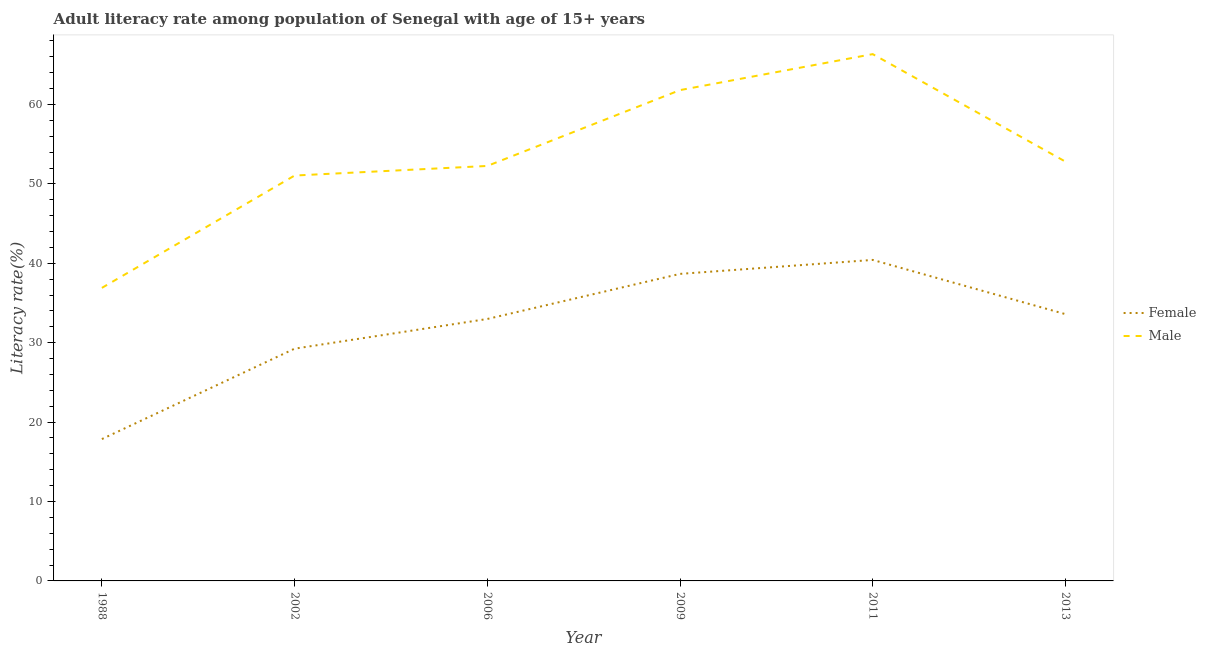Is the number of lines equal to the number of legend labels?
Make the answer very short. Yes. What is the male adult literacy rate in 1988?
Give a very brief answer. 36.9. Across all years, what is the maximum female adult literacy rate?
Offer a terse response. 40.42. Across all years, what is the minimum female adult literacy rate?
Give a very brief answer. 17.86. What is the total female adult literacy rate in the graph?
Your answer should be very brief. 192.79. What is the difference between the female adult literacy rate in 2002 and that in 2009?
Offer a terse response. -9.42. What is the difference between the female adult literacy rate in 2009 and the male adult literacy rate in 2006?
Offer a very short reply. -13.59. What is the average male adult literacy rate per year?
Provide a succinct answer. 53.53. In the year 2011, what is the difference between the male adult literacy rate and female adult literacy rate?
Offer a very short reply. 25.92. In how many years, is the male adult literacy rate greater than 4 %?
Your answer should be compact. 6. What is the ratio of the female adult literacy rate in 2002 to that in 2013?
Your answer should be compact. 0.87. What is the difference between the highest and the second highest female adult literacy rate?
Your answer should be very brief. 1.76. What is the difference between the highest and the lowest male adult literacy rate?
Keep it short and to the point. 29.44. In how many years, is the female adult literacy rate greater than the average female adult literacy rate taken over all years?
Provide a succinct answer. 4. How many lines are there?
Make the answer very short. 2. How many years are there in the graph?
Ensure brevity in your answer.  6. Are the values on the major ticks of Y-axis written in scientific E-notation?
Provide a succinct answer. No. Where does the legend appear in the graph?
Your answer should be compact. Center right. What is the title of the graph?
Provide a short and direct response. Adult literacy rate among population of Senegal with age of 15+ years. Does "Number of arrivals" appear as one of the legend labels in the graph?
Ensure brevity in your answer.  No. What is the label or title of the X-axis?
Make the answer very short. Year. What is the label or title of the Y-axis?
Provide a succinct answer. Literacy rate(%). What is the Literacy rate(%) of Female in 1988?
Make the answer very short. 17.86. What is the Literacy rate(%) in Male in 1988?
Your answer should be compact. 36.9. What is the Literacy rate(%) of Female in 2002?
Offer a terse response. 29.25. What is the Literacy rate(%) of Male in 2002?
Provide a succinct answer. 51.05. What is the Literacy rate(%) in Female in 2006?
Give a very brief answer. 32.99. What is the Literacy rate(%) of Male in 2006?
Your answer should be compact. 52.26. What is the Literacy rate(%) of Female in 2009?
Give a very brief answer. 38.67. What is the Literacy rate(%) in Male in 2009?
Provide a short and direct response. 61.81. What is the Literacy rate(%) in Female in 2011?
Make the answer very short. 40.42. What is the Literacy rate(%) of Male in 2011?
Make the answer very short. 66.34. What is the Literacy rate(%) in Female in 2013?
Provide a succinct answer. 33.6. What is the Literacy rate(%) of Male in 2013?
Your answer should be very brief. 52.8. Across all years, what is the maximum Literacy rate(%) in Female?
Keep it short and to the point. 40.42. Across all years, what is the maximum Literacy rate(%) of Male?
Offer a terse response. 66.34. Across all years, what is the minimum Literacy rate(%) of Female?
Your answer should be very brief. 17.86. Across all years, what is the minimum Literacy rate(%) in Male?
Your answer should be compact. 36.9. What is the total Literacy rate(%) in Female in the graph?
Make the answer very short. 192.79. What is the total Literacy rate(%) of Male in the graph?
Provide a short and direct response. 321.17. What is the difference between the Literacy rate(%) in Female in 1988 and that in 2002?
Make the answer very short. -11.38. What is the difference between the Literacy rate(%) of Male in 1988 and that in 2002?
Keep it short and to the point. -14.15. What is the difference between the Literacy rate(%) of Female in 1988 and that in 2006?
Ensure brevity in your answer.  -15.12. What is the difference between the Literacy rate(%) of Male in 1988 and that in 2006?
Your response must be concise. -15.36. What is the difference between the Literacy rate(%) of Female in 1988 and that in 2009?
Make the answer very short. -20.8. What is the difference between the Literacy rate(%) in Male in 1988 and that in 2009?
Ensure brevity in your answer.  -24.91. What is the difference between the Literacy rate(%) of Female in 1988 and that in 2011?
Offer a terse response. -22.56. What is the difference between the Literacy rate(%) of Male in 1988 and that in 2011?
Provide a short and direct response. -29.44. What is the difference between the Literacy rate(%) of Female in 1988 and that in 2013?
Offer a very short reply. -15.73. What is the difference between the Literacy rate(%) in Male in 1988 and that in 2013?
Provide a short and direct response. -15.9. What is the difference between the Literacy rate(%) of Female in 2002 and that in 2006?
Your answer should be very brief. -3.74. What is the difference between the Literacy rate(%) of Male in 2002 and that in 2006?
Give a very brief answer. -1.21. What is the difference between the Literacy rate(%) of Female in 2002 and that in 2009?
Ensure brevity in your answer.  -9.42. What is the difference between the Literacy rate(%) of Male in 2002 and that in 2009?
Your answer should be very brief. -10.76. What is the difference between the Literacy rate(%) in Female in 2002 and that in 2011?
Your answer should be very brief. -11.18. What is the difference between the Literacy rate(%) in Male in 2002 and that in 2011?
Make the answer very short. -15.29. What is the difference between the Literacy rate(%) of Female in 2002 and that in 2013?
Your answer should be very brief. -4.35. What is the difference between the Literacy rate(%) of Male in 2002 and that in 2013?
Keep it short and to the point. -1.75. What is the difference between the Literacy rate(%) in Female in 2006 and that in 2009?
Your answer should be very brief. -5.68. What is the difference between the Literacy rate(%) in Male in 2006 and that in 2009?
Offer a very short reply. -9.55. What is the difference between the Literacy rate(%) of Female in 2006 and that in 2011?
Provide a succinct answer. -7.44. What is the difference between the Literacy rate(%) in Male in 2006 and that in 2011?
Keep it short and to the point. -14.08. What is the difference between the Literacy rate(%) in Female in 2006 and that in 2013?
Offer a very short reply. -0.61. What is the difference between the Literacy rate(%) in Male in 2006 and that in 2013?
Offer a very short reply. -0.55. What is the difference between the Literacy rate(%) in Female in 2009 and that in 2011?
Offer a terse response. -1.76. What is the difference between the Literacy rate(%) of Male in 2009 and that in 2011?
Make the answer very short. -4.53. What is the difference between the Literacy rate(%) in Female in 2009 and that in 2013?
Ensure brevity in your answer.  5.07. What is the difference between the Literacy rate(%) of Male in 2009 and that in 2013?
Keep it short and to the point. 9.01. What is the difference between the Literacy rate(%) of Female in 2011 and that in 2013?
Give a very brief answer. 6.83. What is the difference between the Literacy rate(%) in Male in 2011 and that in 2013?
Make the answer very short. 13.54. What is the difference between the Literacy rate(%) in Female in 1988 and the Literacy rate(%) in Male in 2002?
Give a very brief answer. -33.19. What is the difference between the Literacy rate(%) of Female in 1988 and the Literacy rate(%) of Male in 2006?
Provide a succinct answer. -34.4. What is the difference between the Literacy rate(%) in Female in 1988 and the Literacy rate(%) in Male in 2009?
Ensure brevity in your answer.  -43.95. What is the difference between the Literacy rate(%) of Female in 1988 and the Literacy rate(%) of Male in 2011?
Ensure brevity in your answer.  -48.48. What is the difference between the Literacy rate(%) of Female in 1988 and the Literacy rate(%) of Male in 2013?
Your response must be concise. -34.94. What is the difference between the Literacy rate(%) of Female in 2002 and the Literacy rate(%) of Male in 2006?
Your answer should be very brief. -23.01. What is the difference between the Literacy rate(%) in Female in 2002 and the Literacy rate(%) in Male in 2009?
Offer a very short reply. -32.56. What is the difference between the Literacy rate(%) of Female in 2002 and the Literacy rate(%) of Male in 2011?
Your answer should be very brief. -37.09. What is the difference between the Literacy rate(%) in Female in 2002 and the Literacy rate(%) in Male in 2013?
Offer a terse response. -23.56. What is the difference between the Literacy rate(%) in Female in 2006 and the Literacy rate(%) in Male in 2009?
Give a very brief answer. -28.82. What is the difference between the Literacy rate(%) in Female in 2006 and the Literacy rate(%) in Male in 2011?
Keep it short and to the point. -33.35. What is the difference between the Literacy rate(%) in Female in 2006 and the Literacy rate(%) in Male in 2013?
Keep it short and to the point. -19.82. What is the difference between the Literacy rate(%) of Female in 2009 and the Literacy rate(%) of Male in 2011?
Offer a terse response. -27.68. What is the difference between the Literacy rate(%) of Female in 2009 and the Literacy rate(%) of Male in 2013?
Your response must be concise. -14.14. What is the difference between the Literacy rate(%) of Female in 2011 and the Literacy rate(%) of Male in 2013?
Provide a short and direct response. -12.38. What is the average Literacy rate(%) in Female per year?
Your answer should be compact. 32.13. What is the average Literacy rate(%) in Male per year?
Ensure brevity in your answer.  53.53. In the year 1988, what is the difference between the Literacy rate(%) of Female and Literacy rate(%) of Male?
Make the answer very short. -19.04. In the year 2002, what is the difference between the Literacy rate(%) of Female and Literacy rate(%) of Male?
Ensure brevity in your answer.  -21.8. In the year 2006, what is the difference between the Literacy rate(%) of Female and Literacy rate(%) of Male?
Provide a short and direct response. -19.27. In the year 2009, what is the difference between the Literacy rate(%) in Female and Literacy rate(%) in Male?
Keep it short and to the point. -23.14. In the year 2011, what is the difference between the Literacy rate(%) in Female and Literacy rate(%) in Male?
Ensure brevity in your answer.  -25.92. In the year 2013, what is the difference between the Literacy rate(%) in Female and Literacy rate(%) in Male?
Your answer should be very brief. -19.21. What is the ratio of the Literacy rate(%) of Female in 1988 to that in 2002?
Provide a succinct answer. 0.61. What is the ratio of the Literacy rate(%) of Male in 1988 to that in 2002?
Offer a very short reply. 0.72. What is the ratio of the Literacy rate(%) of Female in 1988 to that in 2006?
Make the answer very short. 0.54. What is the ratio of the Literacy rate(%) in Male in 1988 to that in 2006?
Ensure brevity in your answer.  0.71. What is the ratio of the Literacy rate(%) of Female in 1988 to that in 2009?
Offer a very short reply. 0.46. What is the ratio of the Literacy rate(%) in Male in 1988 to that in 2009?
Provide a succinct answer. 0.6. What is the ratio of the Literacy rate(%) of Female in 1988 to that in 2011?
Ensure brevity in your answer.  0.44. What is the ratio of the Literacy rate(%) of Male in 1988 to that in 2011?
Your answer should be very brief. 0.56. What is the ratio of the Literacy rate(%) of Female in 1988 to that in 2013?
Ensure brevity in your answer.  0.53. What is the ratio of the Literacy rate(%) in Male in 1988 to that in 2013?
Offer a terse response. 0.7. What is the ratio of the Literacy rate(%) in Female in 2002 to that in 2006?
Keep it short and to the point. 0.89. What is the ratio of the Literacy rate(%) in Male in 2002 to that in 2006?
Make the answer very short. 0.98. What is the ratio of the Literacy rate(%) in Female in 2002 to that in 2009?
Provide a short and direct response. 0.76. What is the ratio of the Literacy rate(%) in Male in 2002 to that in 2009?
Offer a very short reply. 0.83. What is the ratio of the Literacy rate(%) in Female in 2002 to that in 2011?
Offer a very short reply. 0.72. What is the ratio of the Literacy rate(%) of Male in 2002 to that in 2011?
Make the answer very short. 0.77. What is the ratio of the Literacy rate(%) of Female in 2002 to that in 2013?
Your answer should be compact. 0.87. What is the ratio of the Literacy rate(%) of Male in 2002 to that in 2013?
Give a very brief answer. 0.97. What is the ratio of the Literacy rate(%) of Female in 2006 to that in 2009?
Ensure brevity in your answer.  0.85. What is the ratio of the Literacy rate(%) in Male in 2006 to that in 2009?
Your answer should be compact. 0.85. What is the ratio of the Literacy rate(%) of Female in 2006 to that in 2011?
Offer a very short reply. 0.82. What is the ratio of the Literacy rate(%) of Male in 2006 to that in 2011?
Your answer should be very brief. 0.79. What is the ratio of the Literacy rate(%) in Female in 2006 to that in 2013?
Your answer should be compact. 0.98. What is the ratio of the Literacy rate(%) of Female in 2009 to that in 2011?
Provide a succinct answer. 0.96. What is the ratio of the Literacy rate(%) in Male in 2009 to that in 2011?
Keep it short and to the point. 0.93. What is the ratio of the Literacy rate(%) in Female in 2009 to that in 2013?
Keep it short and to the point. 1.15. What is the ratio of the Literacy rate(%) in Male in 2009 to that in 2013?
Your answer should be very brief. 1.17. What is the ratio of the Literacy rate(%) in Female in 2011 to that in 2013?
Your answer should be compact. 1.2. What is the ratio of the Literacy rate(%) in Male in 2011 to that in 2013?
Keep it short and to the point. 1.26. What is the difference between the highest and the second highest Literacy rate(%) in Female?
Offer a terse response. 1.76. What is the difference between the highest and the second highest Literacy rate(%) of Male?
Your answer should be compact. 4.53. What is the difference between the highest and the lowest Literacy rate(%) in Female?
Ensure brevity in your answer.  22.56. What is the difference between the highest and the lowest Literacy rate(%) of Male?
Make the answer very short. 29.44. 